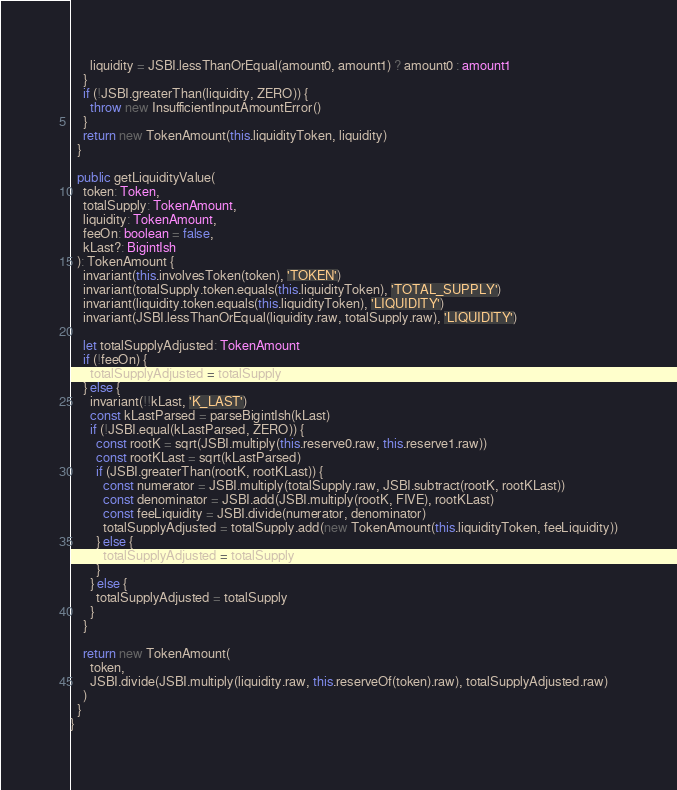Convert code to text. <code><loc_0><loc_0><loc_500><loc_500><_TypeScript_>      liquidity = JSBI.lessThanOrEqual(amount0, amount1) ? amount0 : amount1
    }
    if (!JSBI.greaterThan(liquidity, ZERO)) {
      throw new InsufficientInputAmountError()
    }
    return new TokenAmount(this.liquidityToken, liquidity)
  }

  public getLiquidityValue(
    token: Token,
    totalSupply: TokenAmount,
    liquidity: TokenAmount,
    feeOn: boolean = false,
    kLast?: BigintIsh
  ): TokenAmount {
    invariant(this.involvesToken(token), 'TOKEN')
    invariant(totalSupply.token.equals(this.liquidityToken), 'TOTAL_SUPPLY')
    invariant(liquidity.token.equals(this.liquidityToken), 'LIQUIDITY')
    invariant(JSBI.lessThanOrEqual(liquidity.raw, totalSupply.raw), 'LIQUIDITY')

    let totalSupplyAdjusted: TokenAmount
    if (!feeOn) {
      totalSupplyAdjusted = totalSupply
    } else {
      invariant(!!kLast, 'K_LAST')
      const kLastParsed = parseBigintIsh(kLast)
      if (!JSBI.equal(kLastParsed, ZERO)) {
        const rootK = sqrt(JSBI.multiply(this.reserve0.raw, this.reserve1.raw))
        const rootKLast = sqrt(kLastParsed)
        if (JSBI.greaterThan(rootK, rootKLast)) {
          const numerator = JSBI.multiply(totalSupply.raw, JSBI.subtract(rootK, rootKLast))
          const denominator = JSBI.add(JSBI.multiply(rootK, FIVE), rootKLast)
          const feeLiquidity = JSBI.divide(numerator, denominator)
          totalSupplyAdjusted = totalSupply.add(new TokenAmount(this.liquidityToken, feeLiquidity))
        } else {
          totalSupplyAdjusted = totalSupply
        }
      } else {
        totalSupplyAdjusted = totalSupply
      }
    }

    return new TokenAmount(
      token,
      JSBI.divide(JSBI.multiply(liquidity.raw, this.reserveOf(token).raw), totalSupplyAdjusted.raw)
    )
  }
}
</code> 